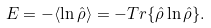Convert formula to latex. <formula><loc_0><loc_0><loc_500><loc_500>E = - \langle \ln \hat { \rho } \rangle = - T r \{ \hat { \rho } \ln \hat { \rho } \} .</formula> 